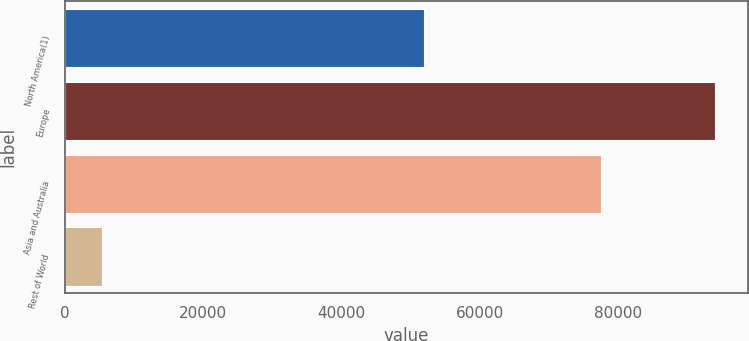Convert chart to OTSL. <chart><loc_0><loc_0><loc_500><loc_500><bar_chart><fcel>North America(1)<fcel>Europe<fcel>Asia and Australia<fcel>Rest of World<nl><fcel>52018<fcel>94077<fcel>77582<fcel>5399<nl></chart> 